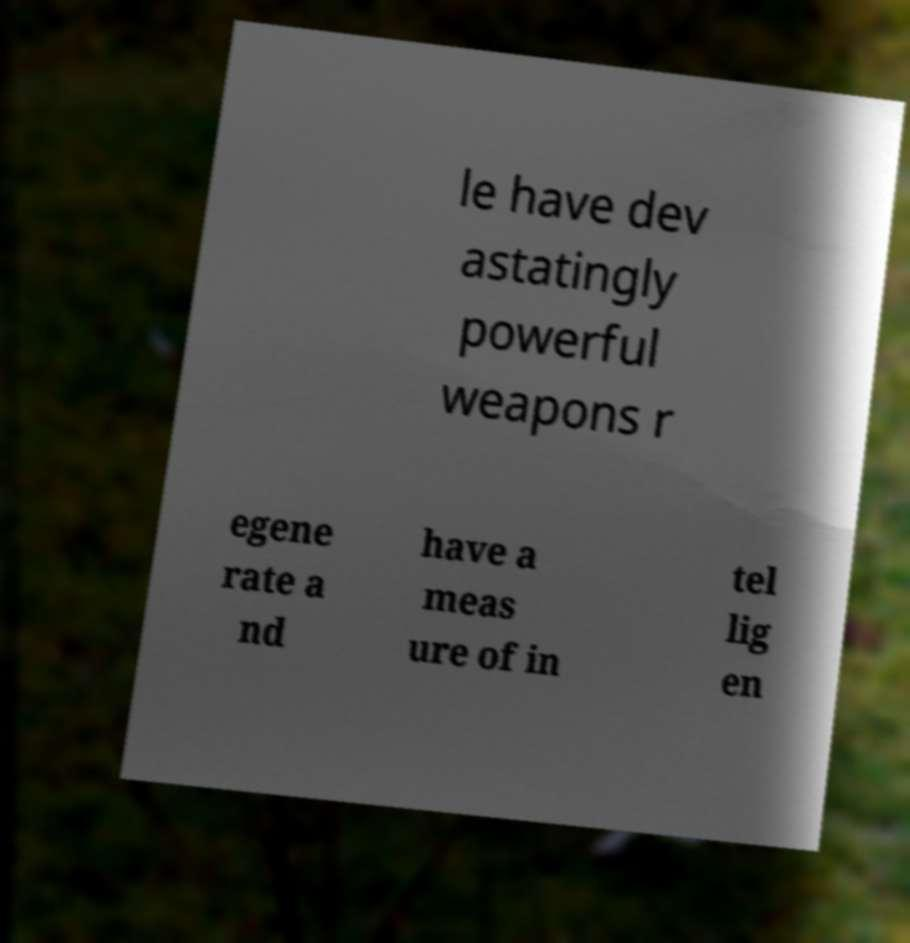What messages or text are displayed in this image? I need them in a readable, typed format. le have dev astatingly powerful weapons r egene rate a nd have a meas ure of in tel lig en 